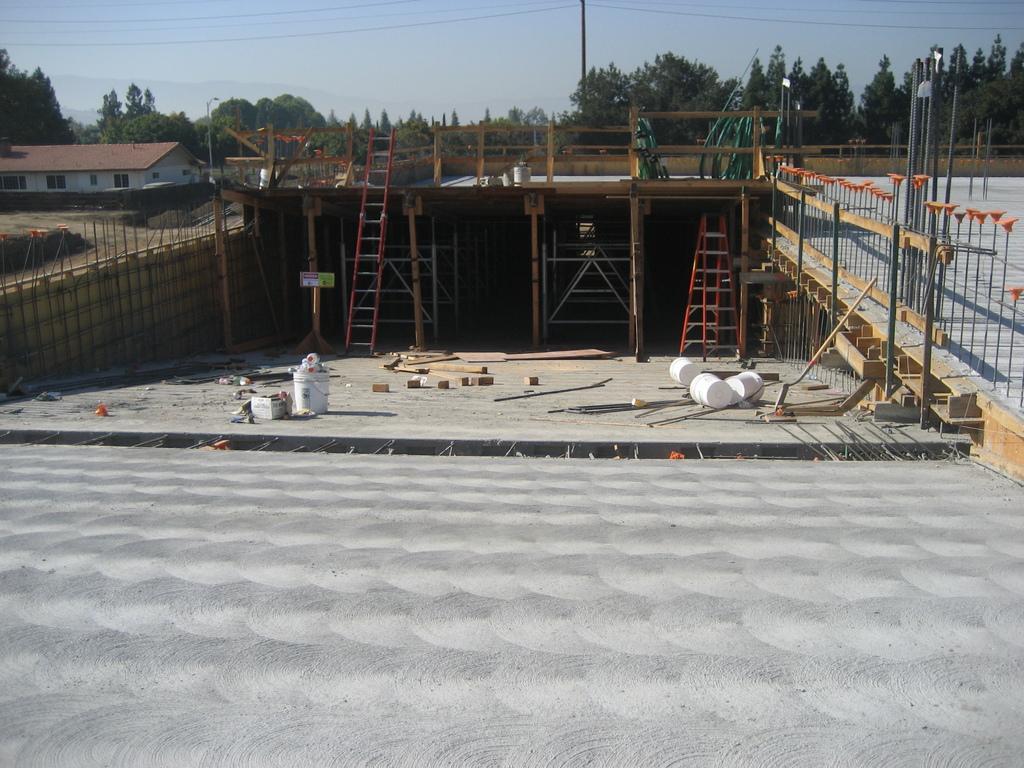How would you summarize this image in a sentence or two? In this image, I can see the buckets and few other things are lying on the ground. These are the ladders. I can see the poles and wooden sticks. This is a house with windows. These are the trees. This looks like a current pole with the current wires hanging. 